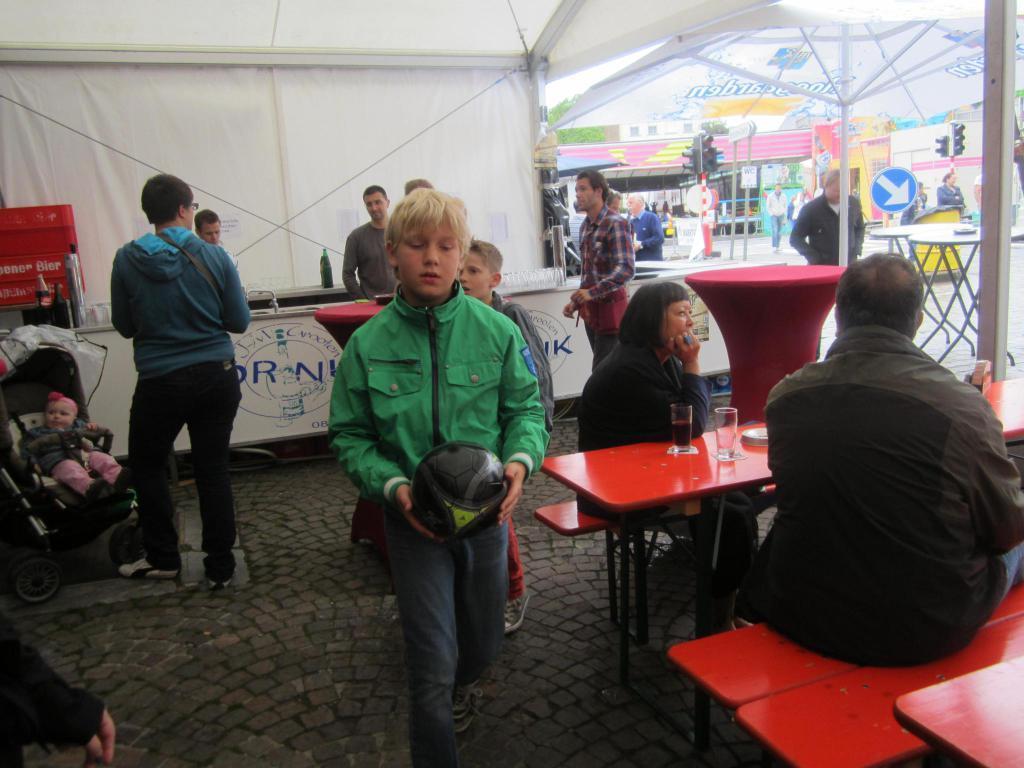Describe this image in one or two sentences. This picture describes about group of people some are seated on the chair, some are walking and some are standing. In front of seated people we can see glasses on the table and they are all in the tent. In the background we can see some sign boards, traffic lights, trees and couple of buildings. 